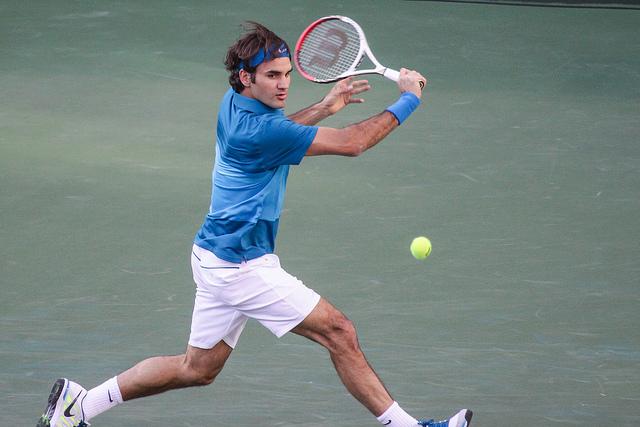What brand of tennis shoes is the player wearing?
Short answer required. Nike. What color is the ball?
Give a very brief answer. Yellow. What sport is being played?
Give a very brief answer. Tennis. Is the player wearing a ponytail?
Short answer required. No. What color are his shorts?
Answer briefly. White. What color is the person's headband?
Write a very short answer. Blue. 